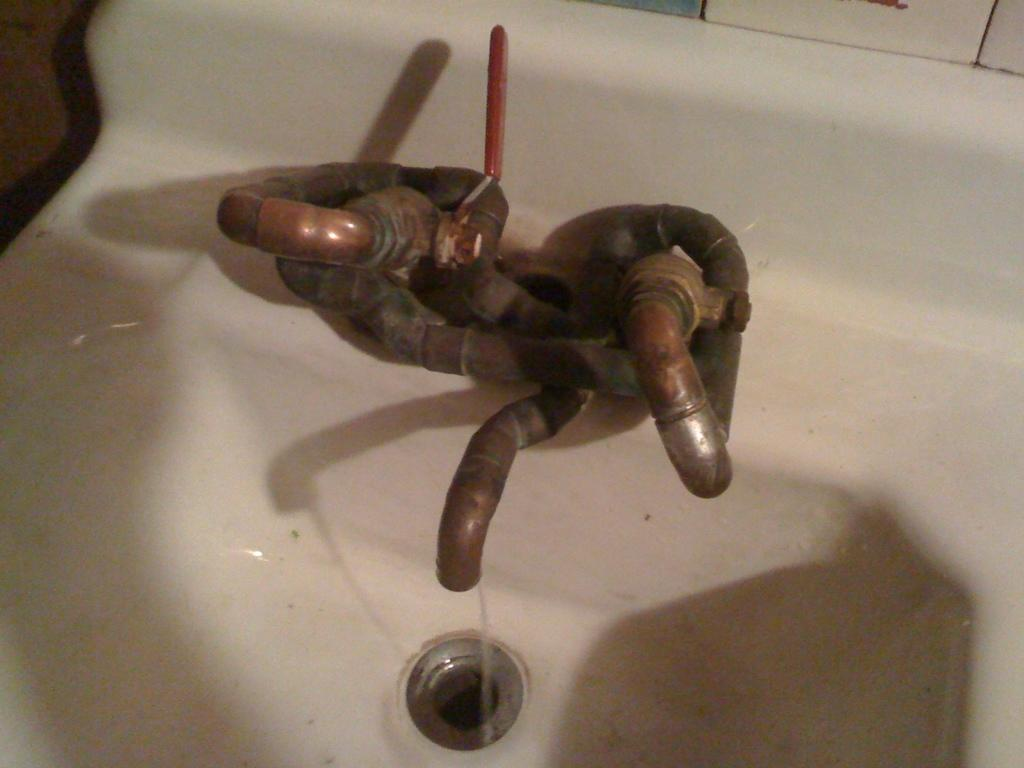What type of basin is present in the image? There is a white color wash basin in the image. What feature is present on the wash basin? The wash basin has taps on it. Can you describe the liquid visible in the image? Water is visible in the image. What type of banana is being used to express anger in the image? There is no banana present in the image, nor is there any expression of anger. 